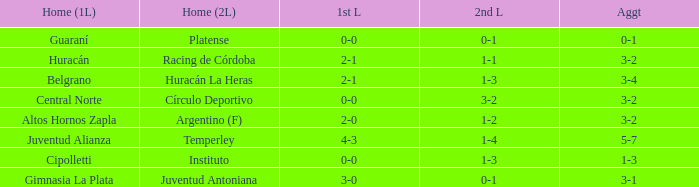What was the aggregate score that had a 1-2 second leg score? 3-2. 